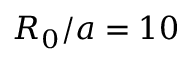<formula> <loc_0><loc_0><loc_500><loc_500>R _ { 0 } / a = 1 0</formula> 